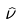<formula> <loc_0><loc_0><loc_500><loc_500>\hat { \nu }</formula> 